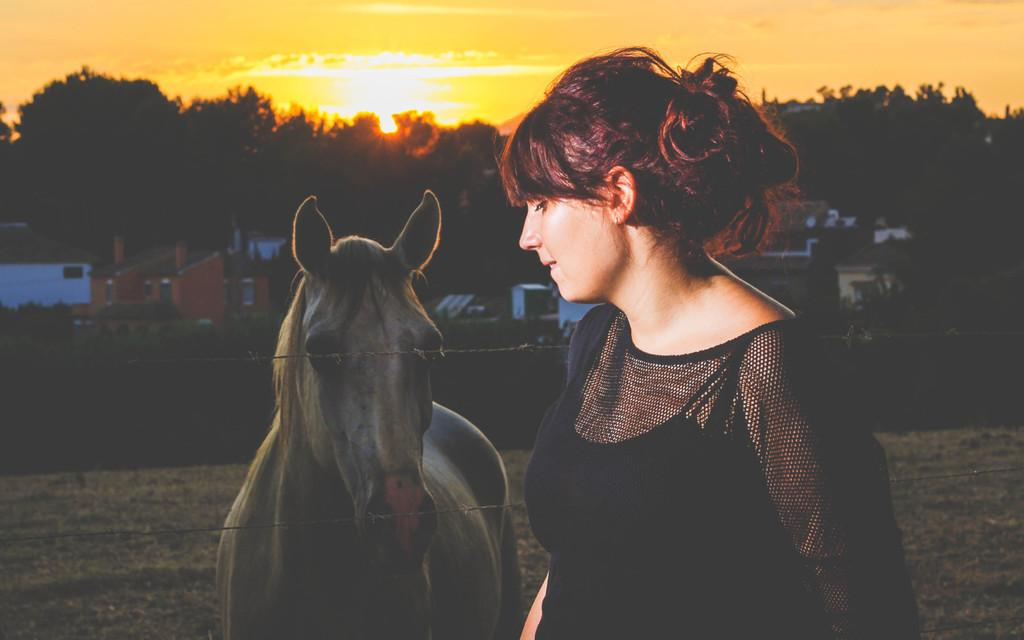What color is the dress the woman is wearing in the image? The woman is wearing a black dress in the image. What animal is beside the woman? There is a horse beside the woman in the image. What can be seen in the background of the image? There are trees and houses in the background of the image. Where is the clover located in the image? There is no clover present in the image. What type of animal is walking down the street in the image? There is no street or animal walking down it in the image. 